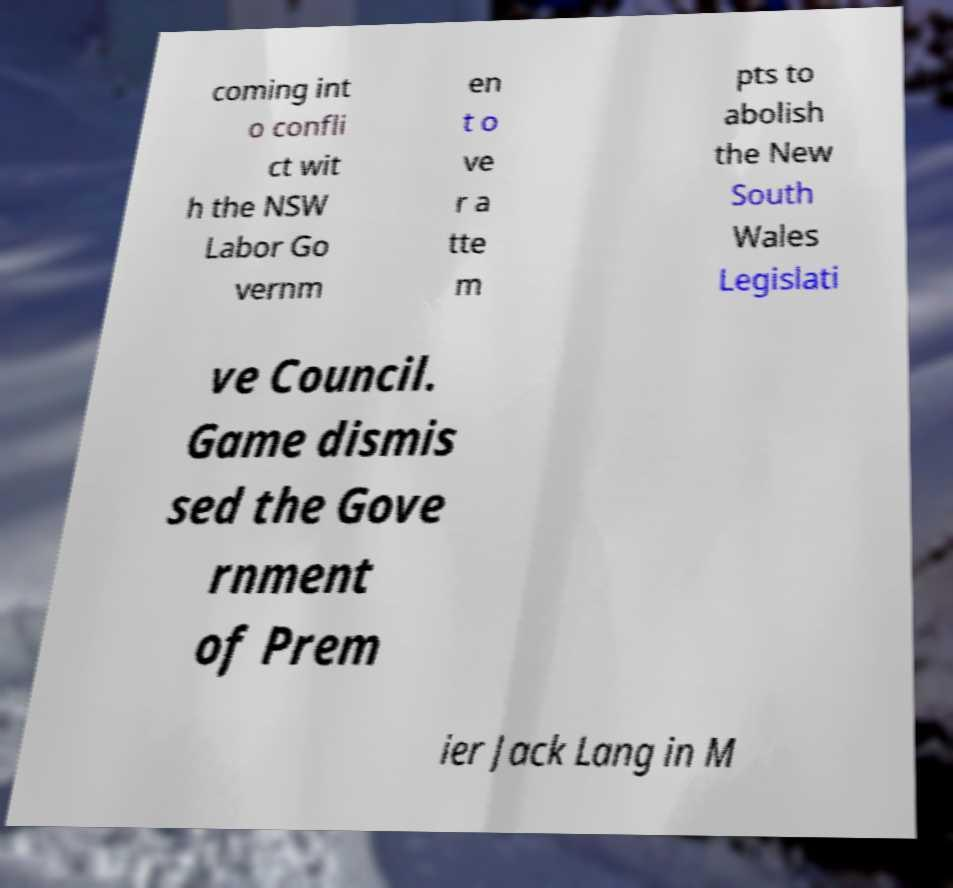I need the written content from this picture converted into text. Can you do that? coming int o confli ct wit h the NSW Labor Go vernm en t o ve r a tte m pts to abolish the New South Wales Legislati ve Council. Game dismis sed the Gove rnment of Prem ier Jack Lang in M 